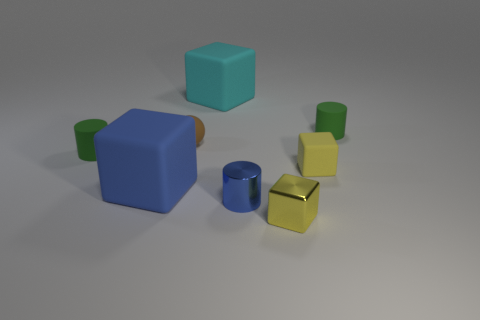Is there any other thing that has the same color as the small matte cube?
Provide a succinct answer. Yes. There is a small green rubber object that is left of the yellow shiny cube; what shape is it?
Keep it short and to the point. Cylinder. There is a rubber thing that is both on the right side of the brown sphere and on the left side of the metal cube; what is its shape?
Your answer should be very brief. Cube. How many purple objects are matte blocks or shiny cylinders?
Your response must be concise. 0. Is the color of the large matte thing that is in front of the large cyan object the same as the metallic cube?
Ensure brevity in your answer.  No. How big is the cube in front of the cube on the left side of the cyan object?
Provide a succinct answer. Small. There is a blue block that is the same size as the cyan block; what is it made of?
Offer a terse response. Rubber. What number of other things are the same size as the blue rubber object?
Offer a very short reply. 1. What number of balls are either large blue rubber things or tiny brown things?
Your answer should be very brief. 1. Is there anything else that is the same material as the brown thing?
Ensure brevity in your answer.  Yes. 